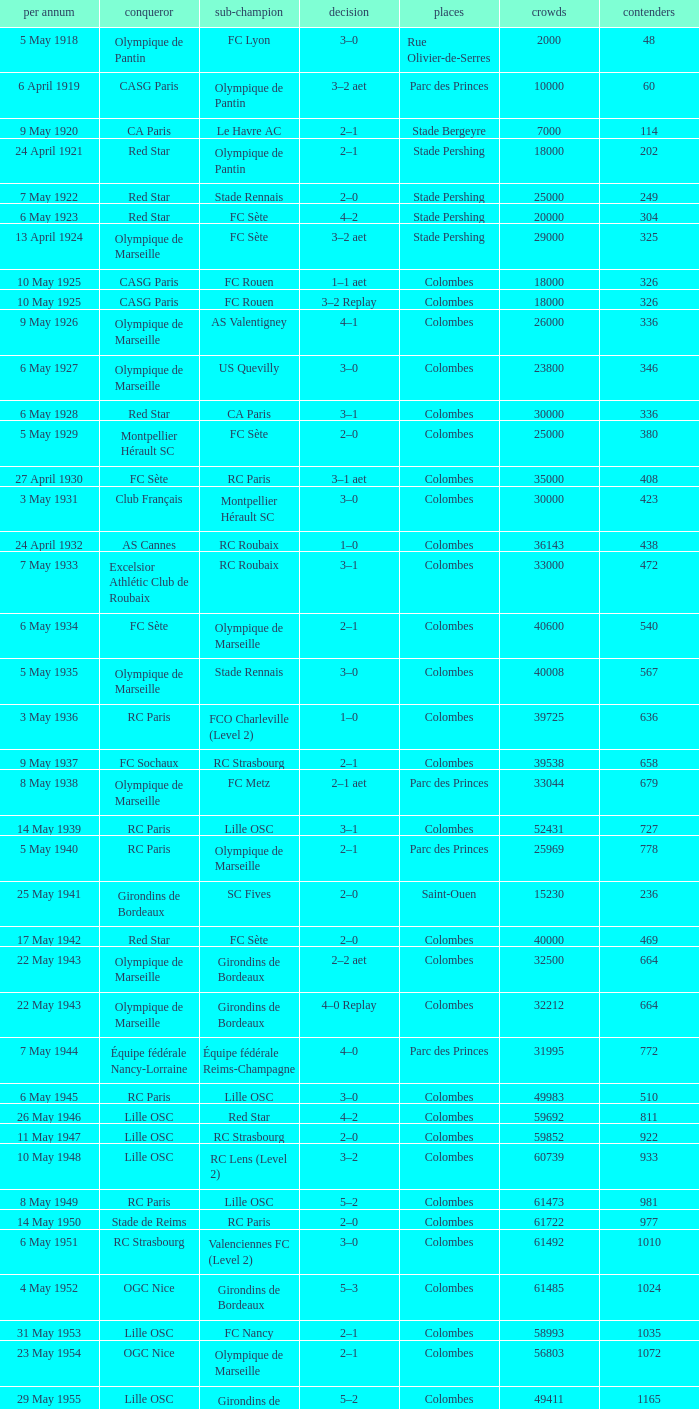Write the full table. {'header': ['per annum', 'conqueror', 'sub-champion', 'decision', 'places', 'crowds', 'contenders'], 'rows': [['5 May 1918', 'Olympique de Pantin', 'FC Lyon', '3–0', 'Rue Olivier-de-Serres', '2000', '48'], ['6 April 1919', 'CASG Paris', 'Olympique de Pantin', '3–2 aet', 'Parc des Princes', '10000', '60'], ['9 May 1920', 'CA Paris', 'Le Havre AC', '2–1', 'Stade Bergeyre', '7000', '114'], ['24 April 1921', 'Red Star', 'Olympique de Pantin', '2–1', 'Stade Pershing', '18000', '202'], ['7 May 1922', 'Red Star', 'Stade Rennais', '2–0', 'Stade Pershing', '25000', '249'], ['6 May 1923', 'Red Star', 'FC Sète', '4–2', 'Stade Pershing', '20000', '304'], ['13 April 1924', 'Olympique de Marseille', 'FC Sète', '3–2 aet', 'Stade Pershing', '29000', '325'], ['10 May 1925', 'CASG Paris', 'FC Rouen', '1–1 aet', 'Colombes', '18000', '326'], ['10 May 1925', 'CASG Paris', 'FC Rouen', '3–2 Replay', 'Colombes', '18000', '326'], ['9 May 1926', 'Olympique de Marseille', 'AS Valentigney', '4–1', 'Colombes', '26000', '336'], ['6 May 1927', 'Olympique de Marseille', 'US Quevilly', '3–0', 'Colombes', '23800', '346'], ['6 May 1928', 'Red Star', 'CA Paris', '3–1', 'Colombes', '30000', '336'], ['5 May 1929', 'Montpellier Hérault SC', 'FC Sète', '2–0', 'Colombes', '25000', '380'], ['27 April 1930', 'FC Sète', 'RC Paris', '3–1 aet', 'Colombes', '35000', '408'], ['3 May 1931', 'Club Français', 'Montpellier Hérault SC', '3–0', 'Colombes', '30000', '423'], ['24 April 1932', 'AS Cannes', 'RC Roubaix', '1–0', 'Colombes', '36143', '438'], ['7 May 1933', 'Excelsior Athlétic Club de Roubaix', 'RC Roubaix', '3–1', 'Colombes', '33000', '472'], ['6 May 1934', 'FC Sète', 'Olympique de Marseille', '2–1', 'Colombes', '40600', '540'], ['5 May 1935', 'Olympique de Marseille', 'Stade Rennais', '3–0', 'Colombes', '40008', '567'], ['3 May 1936', 'RC Paris', 'FCO Charleville (Level 2)', '1–0', 'Colombes', '39725', '636'], ['9 May 1937', 'FC Sochaux', 'RC Strasbourg', '2–1', 'Colombes', '39538', '658'], ['8 May 1938', 'Olympique de Marseille', 'FC Metz', '2–1 aet', 'Parc des Princes', '33044', '679'], ['14 May 1939', 'RC Paris', 'Lille OSC', '3–1', 'Colombes', '52431', '727'], ['5 May 1940', 'RC Paris', 'Olympique de Marseille', '2–1', 'Parc des Princes', '25969', '778'], ['25 May 1941', 'Girondins de Bordeaux', 'SC Fives', '2–0', 'Saint-Ouen', '15230', '236'], ['17 May 1942', 'Red Star', 'FC Sète', '2–0', 'Colombes', '40000', '469'], ['22 May 1943', 'Olympique de Marseille', 'Girondins de Bordeaux', '2–2 aet', 'Colombes', '32500', '664'], ['22 May 1943', 'Olympique de Marseille', 'Girondins de Bordeaux', '4–0 Replay', 'Colombes', '32212', '664'], ['7 May 1944', 'Équipe fédérale Nancy-Lorraine', 'Équipe fédérale Reims-Champagne', '4–0', 'Parc des Princes', '31995', '772'], ['6 May 1945', 'RC Paris', 'Lille OSC', '3–0', 'Colombes', '49983', '510'], ['26 May 1946', 'Lille OSC', 'Red Star', '4–2', 'Colombes', '59692', '811'], ['11 May 1947', 'Lille OSC', 'RC Strasbourg', '2–0', 'Colombes', '59852', '922'], ['10 May 1948', 'Lille OSC', 'RC Lens (Level 2)', '3–2', 'Colombes', '60739', '933'], ['8 May 1949', 'RC Paris', 'Lille OSC', '5–2', 'Colombes', '61473', '981'], ['14 May 1950', 'Stade de Reims', 'RC Paris', '2–0', 'Colombes', '61722', '977'], ['6 May 1951', 'RC Strasbourg', 'Valenciennes FC (Level 2)', '3–0', 'Colombes', '61492', '1010'], ['4 May 1952', 'OGC Nice', 'Girondins de Bordeaux', '5–3', 'Colombes', '61485', '1024'], ['31 May 1953', 'Lille OSC', 'FC Nancy', '2–1', 'Colombes', '58993', '1035'], ['23 May 1954', 'OGC Nice', 'Olympique de Marseille', '2–1', 'Colombes', '56803', '1072'], ['29 May 1955', 'Lille OSC', 'Girondins de Bordeaux', '5–2', 'Colombes', '49411', '1165'], ['27 May 1956', 'CS Sedan', 'ES Troyes AC', '3–1', 'Colombes', '47258', '1203'], ['26 May 1957', 'Toulouse FC', 'SCO Angers', '6–3', 'Colombes', '43125', '1149'], ['18 May 1958', 'Stade de Reims', 'Nîmes Olympique', '3–1', 'Colombes', '56523', '1163'], ['18 May 1959', 'Le Havre AC (Level 2)', 'FC Sochaux', '2–2 aet', 'Colombes', '36655', '1159'], ['18 May 1959', 'Le Havre AC (Level 2)', 'FC Sochaux', '3–0 Replay', 'Colombes', '36655', '1159'], ['15 May 1960', 'AS Monaco', 'AS Saint-Étienne', '4–2 aet', 'Colombes', '38298', '1187'], ['7 May 1961', 'CS Sedan', 'Nîmes Olympique', '3–1', 'Colombes', '39070', '1193'], ['13 May 1962', 'AS Saint-Étienne', 'FC Nancy', '1–0', 'Colombes', '30654', '1226'], ['23 May 1963', 'AS Monaco', 'Olympique Lyonnais', '0–0 aet', 'Colombes', '32923', '1209'], ['23 May 1963', 'AS Monaco', 'Olympique Lyonnais', '2–0 Replay', 'Colombes', '24910', '1209'], ['10 May 1964', 'Olympique Lyonnais', 'Girondins de Bordeaux', '2–0', 'Colombes', '32777', '1203'], ['26 May 1965', 'Stade Rennais', 'CS Sedan', '2–2 aet', 'Parc des Princes', '36789', '1183'], ['26 May 1965', 'Stade Rennais', 'CS Sedan', '3–1 Replay', 'Parc des Princes', '26792', '1183'], ['22 May 1966', 'RC Strasbourg', 'FC Nantes', '1–0', 'Parc des Princes', '36285', '1190'], ['21 May 1967', 'Olympique Lyonnais', 'FC Sochaux', '3–1', 'Parc des Princes', '32523', '1378'], ['12 May 1968', 'AS Saint-Étienne', 'Girondins de Bordeaux', '2–1', 'Colombes', '33959', '1378'], ['18 May 1969', 'Olympique de Marseille', 'Girondins de Bordeaux', '2–0', 'Colombes', '39460', '1377'], ['31 May 1970', 'AS Saint-Étienne', 'FC Nantes', '5–0', 'Colombes', '32894', '1375'], ['20 June 1971', 'Stade Rennais', 'Olympique Lyonnais', '1–0', 'Colombes', '46801', '1383'], ['4 June 1972', 'Olympique de Marseille', 'SC Bastia', '2–1', 'Parc des Princes', '44069', '1596'], ['17 June 1973', 'Olympique Lyonnais', 'FC Nantes', '2–1', 'Parc des Princes', '45734', '1596'], ['8 June 1974', 'AS Saint-Étienne', 'AS Monaco', '2–1', 'Parc des Princes', '45813', '1720'], ['14 June 1975', 'AS Saint-Étienne', 'RC Lens', '2–0', 'Parc des Princes', '44725', '1940'], ['12 June 1976', 'Olympique de Marseille', 'Olympique Lyonnais', '2–0', 'Parc des Princes', '45661', '1977'], ['18 June 1977', 'AS Saint-Étienne', 'Stade de Reims', '2–1', 'Parc des Princes', '45454', '2084'], ['13 May 1978', 'AS Nancy', 'OGC Nice', '1–0', 'Parc des Princes', '45998', '2544'], ['16 June 1979', 'FC Nantes', 'AJ Auxerre (Level 2)', '4–1 aet', 'Parc des Princes', '46070', '2473'], ['7 June 1980', 'AS Monaco', 'US Orléans (Level 2)', '3–1', 'Parc des Princes', '46136', '2473'], ['13 June 1981', 'SC Bastia', 'AS Saint-Étienne', '2–1', 'Parc des Princes', '46155', '2924'], ['15 May 1982', 'Paris SG', 'AS Saint-Étienne', '2–2 aet 6–5 pen', 'Parc des Princes', '46160', '3179'], ['11 June 1983', 'Paris SG', 'FC Nantes', '3–2', 'Parc des Princes', '46203', '3280'], ['11 May 1984', 'FC Metz', 'AS Monaco', '2–0 aet', 'Parc des Princes', '45384', '3705'], ['8 June 1985', 'AS Monaco', 'Paris SG', '1–0', 'Parc des Princes', '45711', '3983'], ['30 April 1986', 'Girondins de Bordeaux', 'Olympique de Marseille', '2–1 aet', 'Parc des Princes', '45429', '4117'], ['10 June 1987', 'Girondins de Bordeaux', 'Olympique de Marseille', '2–0', 'Parc des Princes', '45145', '4964'], ['11 June 1988', 'FC Metz', 'FC Sochaux', '1–1 aet 5–4 pen', 'Parc des Princes', '44531', '5293'], ['10 June 1989', 'Olympique de Marseille', 'AS Monaco', '4–3', 'Parc des Princes', '44448', '5293'], ['2 June 1990', 'Montpellier Hérault SC', 'RC Paris', '2–1 aet', 'Parc des Princes', '44067', '5972'], ['8 June 1991', 'AS Monaco', 'Olympique de Marseille', '1–0', 'Parc des Princes', '44123', '6065'], ['12 June 1993', 'Paris SG', 'FC Nantes', '3–0', 'Parc des Princes', '48789', '6523'], ['14 May 1994', 'AJ Auxerre', 'Montpellier HSC', '3–0', 'Parc des Princes', '45189', '6261'], ['13 May 1995', 'Paris SG', 'RC Strasbourg', '1–0', 'Parc des Princes', '46698', '5975'], ['4 May 1996', 'AJ Auxerre', 'Nîmes Olympique (Level 3)', '2–1', 'Parc des Princes', '44921', '5847'], ['10 May 1997', 'OGC Nice', 'En Avant de Guingamp', '1–1 aet 4–3 pen', 'Parc des Princes', '44131', '5986'], ['2 May 1998', 'Paris SG', 'RC Lens', '2–1', 'Stade de France', '78265', '6106'], ['15 May 1999', 'FC Nantes', 'CS Sedan (Level 2)', '1–0', 'Stade de France', '78586', '5957'], ['7 May 2000', 'FC Nantes', 'Calais RUFC (Level 4)', '2–1', 'Stade de France', '78717', '6096'], ['26 May 2001', 'RC Strasbourg', 'Amiens SC (Level 2)', '0–0 aet 5–4 pen', 'Stade de France', '78641', '6375'], ['11 May 2002', 'FC Lorient', 'SC Bastia', '1–0', 'Stade de France', '66215', '5848'], ['31 May 2003', 'AJ Auxerre', 'Paris SG', '2–1', 'Stade de France', '78316', '5850'], ['29 May 2004', 'Paris SG', 'LB Châteauroux (Level 2)', '1–0', 'Stade de France', '78357', '6057'], ['4 June 2005', 'AJ Auxerre', 'CS Sedan', '2–1', 'Stade de France', '78721', '6263'], ['29 April 2006', 'Paris Saint-Germain', 'Olympique de Marseille', '2–1', 'Stade de France', '79797', '6394'], ['12 May 2007', 'FC Sochaux', 'Olympique de Marseille', '2–2 aet 5–4 pen', 'Stade de France', '79850', '6577'], ['24 May 2008', 'Olympique Lyonnais', 'Paris Saint-Germain', '1–0', 'Stade de France', '79204', '6734'], ['9 May 2009', 'EA Guingamp (Level 2)', 'Stade Rennais', '2–1', 'Stade de France', '80056', '7246'], ['1 May 2010', 'Paris Saint-Germain', 'AS Monaco', '1–0 aet', 'Stade de France', '74000', '7317'], ['14 May 2011', 'Lille', 'Paris Saint-Germain', '1–0', 'Stade de France', '79000', '7449'], ['28 April 2012', 'Olympique Lyonnais', 'US Quevilly (Level 3)', '1–0', 'Stade de France', '76293', '7422']]} What is the fewest recorded entrants against paris saint-germain? 6394.0. 